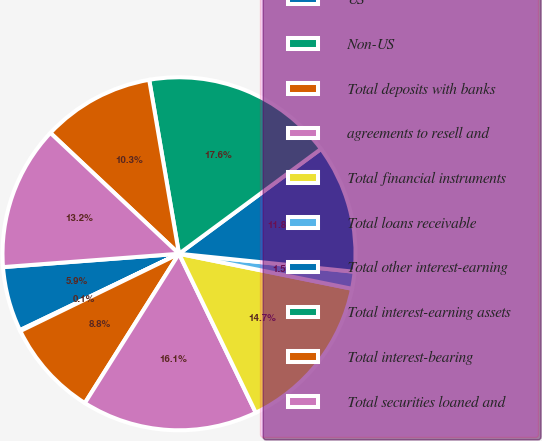Convert chart. <chart><loc_0><loc_0><loc_500><loc_500><pie_chart><fcel>US<fcel>Non-US<fcel>Total deposits with banks<fcel>agreements to resell and<fcel>Total financial instruments<fcel>Total loans receivable<fcel>Total other interest-earning<fcel>Total interest-earning assets<fcel>Total interest-bearing<fcel>Total securities loaned and<nl><fcel>5.92%<fcel>0.09%<fcel>8.83%<fcel>16.12%<fcel>14.66%<fcel>1.55%<fcel>11.75%<fcel>17.58%<fcel>10.29%<fcel>13.21%<nl></chart> 